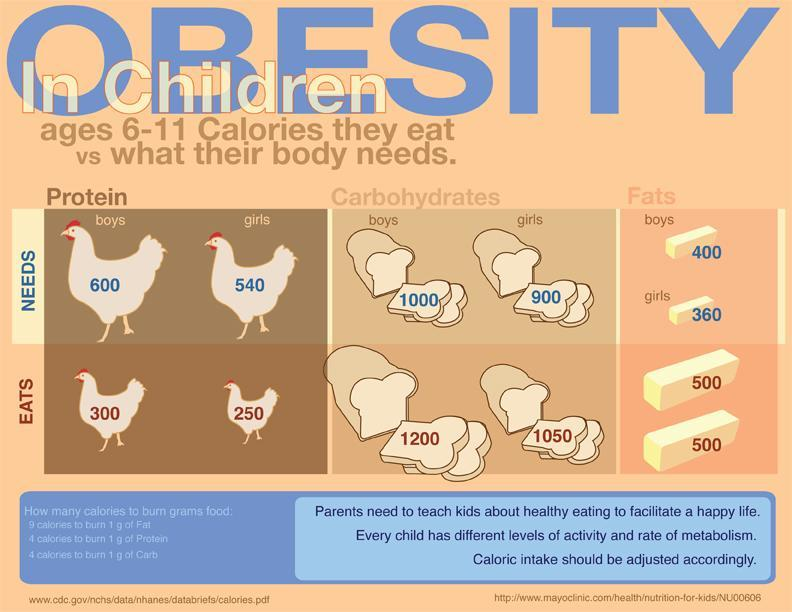What is the difference in protein eaten by boys and girls?
Answer the question with a short phrase. 50 Calories How many sources are listed at the bottom? 2 How much protein is needed by girls? 540 Calories Which nutrient is eaten in same amount by both boys and girls? Fats What is the difference in carbohydrates needed vs eaten for boys? 200 Calories 